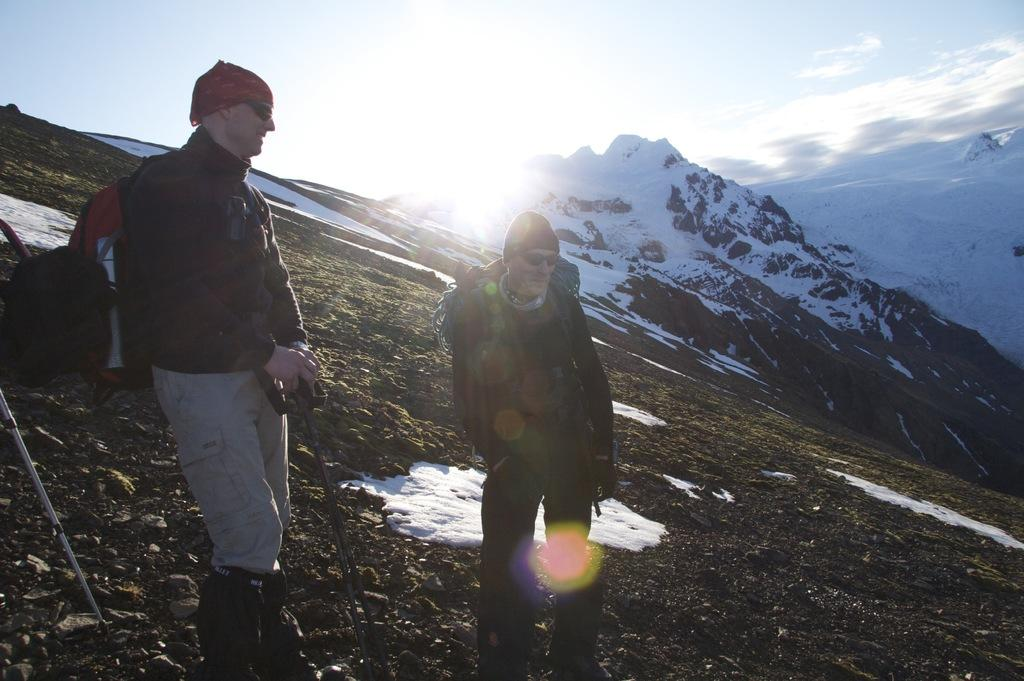How many men are in the image? There are two men in the image. What are the men wearing on their heads? The men are wearing caps. What are the men wearing to protect their eyes? The men are wearing goggles. What are the men carrying in the image? The men are carrying bags. Where are the men standing in the image? The men are standing on the ground. What can be seen in the background of the image? Mountains and the sky are visible in the background. What is the condition of the sky in the image? Clouds are present in the sky. What type of drain is visible in the image? There is no drain present in the image. What kind of produce can be seen growing near the men in the image? There is no produce visible in the image. 